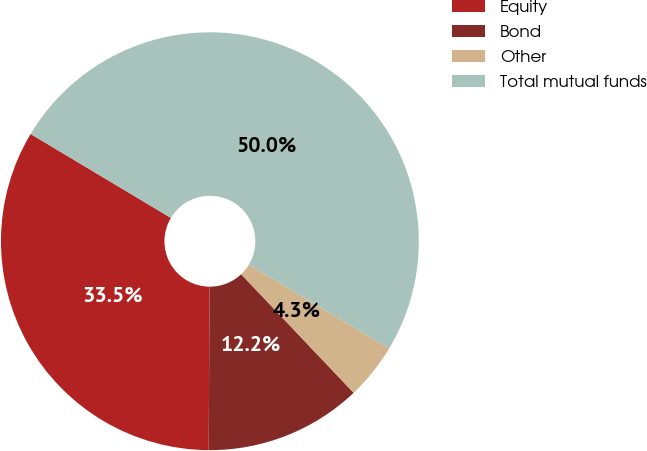<chart> <loc_0><loc_0><loc_500><loc_500><pie_chart><fcel>Equity<fcel>Bond<fcel>Other<fcel>Total mutual funds<nl><fcel>33.49%<fcel>12.17%<fcel>4.34%<fcel>50.0%<nl></chart> 